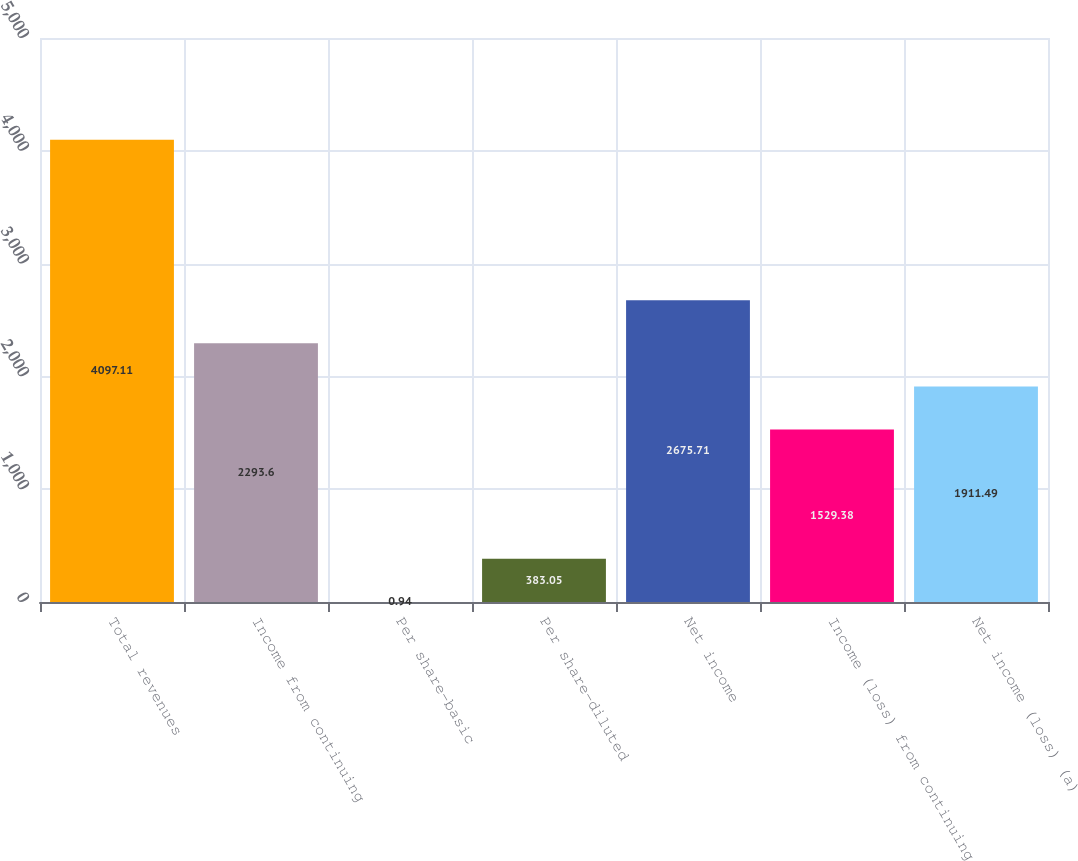Convert chart to OTSL. <chart><loc_0><loc_0><loc_500><loc_500><bar_chart><fcel>Total revenues<fcel>Income from continuing<fcel>Per share-basic<fcel>Per share-diluted<fcel>Net income<fcel>Income (loss) from continuing<fcel>Net income (loss) (a)<nl><fcel>4097.11<fcel>2293.6<fcel>0.94<fcel>383.05<fcel>2675.71<fcel>1529.38<fcel>1911.49<nl></chart> 